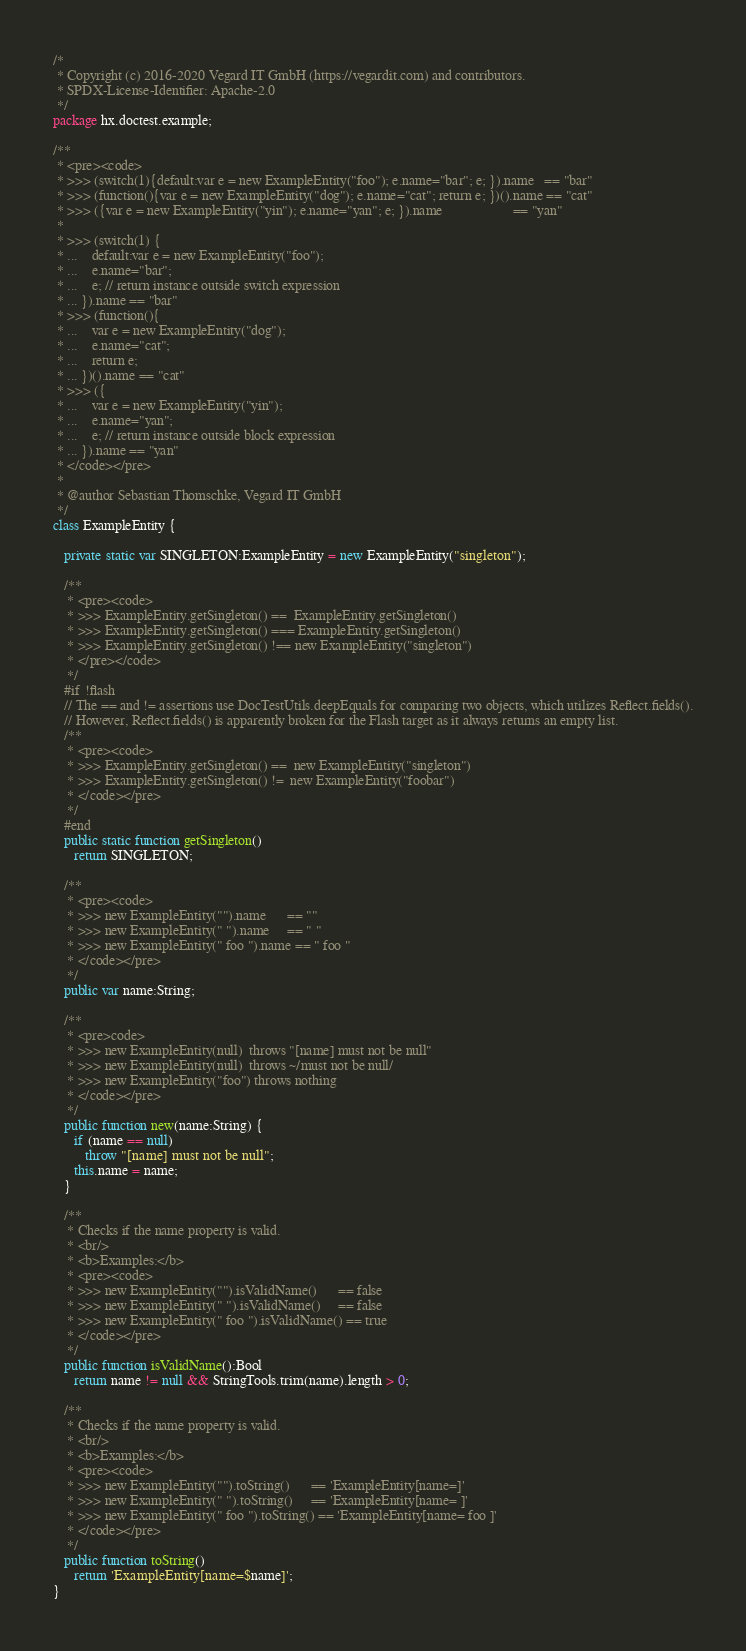Convert code to text. <code><loc_0><loc_0><loc_500><loc_500><_Haxe_>/*
 * Copyright (c) 2016-2020 Vegard IT GmbH (https://vegardit.com) and contributors.
 * SPDX-License-Identifier: Apache-2.0
 */
package hx.doctest.example;

/**
 * <pre><code>
 * >>> (switch(1){default:var e = new ExampleEntity("foo"); e.name="bar"; e; }).name   == "bar"
 * >>> (function(){var e = new ExampleEntity("dog"); e.name="cat"; return e; })().name == "cat"
 * >>> ({var e = new ExampleEntity("yin"); e.name="yan"; e; }).name                    == "yan"
 *
 * >>> (switch(1) {
 * ...    default:var e = new ExampleEntity("foo");
 * ...    e.name="bar";
 * ...    e; // return instance outside switch expression
 * ... }).name == "bar"
 * >>> (function(){
 * ...    var e = new ExampleEntity("dog");
 * ...    e.name="cat";
 * ...    return e;
 * ... })().name == "cat"
 * >>> ({
 * ...    var e = new ExampleEntity("yin");
 * ...    e.name="yan";
 * ...    e; // return instance outside block expression
 * ... }).name == "yan"
 * </code></pre>
 *
 * @author Sebastian Thomschke, Vegard IT GmbH
 */
class ExampleEntity {

   private static var SINGLETON:ExampleEntity = new ExampleEntity("singleton");

   /**
    * <pre><code>
    * >>> ExampleEntity.getSingleton() ==  ExampleEntity.getSingleton()
    * >>> ExampleEntity.getSingleton() === ExampleEntity.getSingleton()
    * >>> ExampleEntity.getSingleton() !== new ExampleEntity("singleton")
    * </pre></code>
    */
   #if !flash
   // The == and != assertions use DocTestUtils.deepEquals for comparing two objects, which utilizes Reflect.fields().
   // However, Reflect.fields() is apparently broken for the Flash target as it always returns an empty list.
   /**
    * <pre><code>
    * >>> ExampleEntity.getSingleton() ==  new ExampleEntity("singleton")
    * >>> ExampleEntity.getSingleton() !=  new ExampleEntity("foobar")
    * </code></pre>
    */
   #end
   public static function getSingleton()
      return SINGLETON;

   /**
    * <pre><code>
    * >>> new ExampleEntity("").name      == ""
    * >>> new ExampleEntity(" ").name     == " "
    * >>> new ExampleEntity(" foo ").name == " foo "
    * </code></pre>
    */
   public var name:String;

   /**
    * <pre>code>
    * >>> new ExampleEntity(null)  throws "[name] must not be null"
    * >>> new ExampleEntity(null)  throws ~/must not be null/
    * >>> new ExampleEntity("foo") throws nothing
    * </code></pre>
    */
   public function new(name:String) {
      if (name == null)
         throw "[name] must not be null";
      this.name = name;
   }

   /**
    * Checks if the name property is valid.
    * <br/>
    * <b>Examples:</b>
    * <pre><code>
    * >>> new ExampleEntity("").isValidName()      == false
    * >>> new ExampleEntity(" ").isValidName()     == false
    * >>> new ExampleEntity(" foo ").isValidName() == true
    * </code></pre>
    */
   public function isValidName():Bool
      return name != null && StringTools.trim(name).length > 0;

   /**
    * Checks if the name property is valid.
    * <br/>
    * <b>Examples:</b>
    * <pre><code>
    * >>> new ExampleEntity("").toString()      == 'ExampleEntity[name=]'
    * >>> new ExampleEntity(" ").toString()     == 'ExampleEntity[name= ]'
    * >>> new ExampleEntity(" foo ").toString() == 'ExampleEntity[name= foo ]'
    * </code></pre>
    */
   public function toString()
      return 'ExampleEntity[name=$name]';
}
</code> 